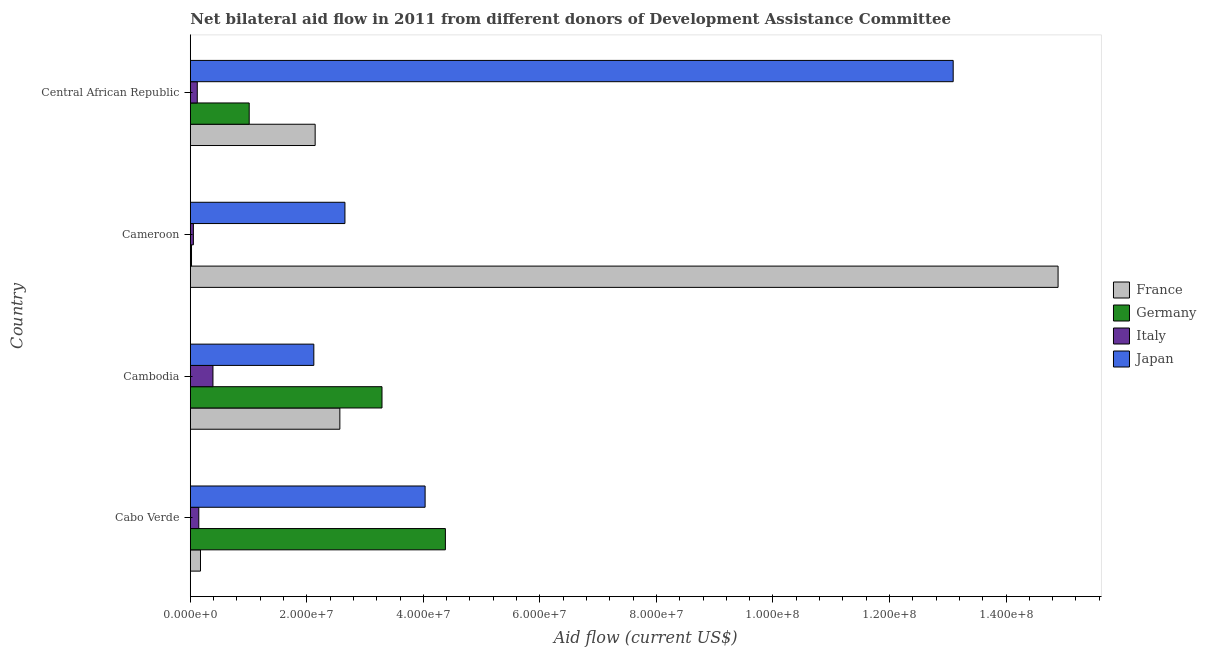How many different coloured bars are there?
Provide a short and direct response. 4. How many groups of bars are there?
Offer a terse response. 4. Are the number of bars per tick equal to the number of legend labels?
Your answer should be very brief. Yes. How many bars are there on the 1st tick from the top?
Your answer should be compact. 4. What is the label of the 1st group of bars from the top?
Ensure brevity in your answer.  Central African Republic. In how many cases, is the number of bars for a given country not equal to the number of legend labels?
Give a very brief answer. 0. What is the amount of aid given by france in Cabo Verde?
Give a very brief answer. 1.75e+06. Across all countries, what is the maximum amount of aid given by japan?
Offer a very short reply. 1.31e+08. Across all countries, what is the minimum amount of aid given by germany?
Offer a very short reply. 2.10e+05. In which country was the amount of aid given by france maximum?
Provide a short and direct response. Cameroon. In which country was the amount of aid given by germany minimum?
Make the answer very short. Cameroon. What is the total amount of aid given by japan in the graph?
Provide a succinct answer. 2.19e+08. What is the difference between the amount of aid given by france in Cabo Verde and that in Cambodia?
Give a very brief answer. -2.39e+07. What is the difference between the amount of aid given by italy in Cambodia and the amount of aid given by germany in Cabo Verde?
Offer a very short reply. -3.99e+07. What is the average amount of aid given by germany per country?
Your response must be concise. 2.18e+07. What is the difference between the amount of aid given by france and amount of aid given by italy in Cameroon?
Ensure brevity in your answer.  1.48e+08. What is the ratio of the amount of aid given by germany in Cabo Verde to that in Cameroon?
Your answer should be compact. 208.48. Is the difference between the amount of aid given by italy in Cameroon and Central African Republic greater than the difference between the amount of aid given by france in Cameroon and Central African Republic?
Keep it short and to the point. No. What is the difference between the highest and the second highest amount of aid given by italy?
Your answer should be very brief. 2.43e+06. What is the difference between the highest and the lowest amount of aid given by germany?
Give a very brief answer. 4.36e+07. In how many countries, is the amount of aid given by france greater than the average amount of aid given by france taken over all countries?
Offer a terse response. 1. Is the sum of the amount of aid given by japan in Cambodia and Cameroon greater than the maximum amount of aid given by italy across all countries?
Provide a succinct answer. Yes. Is it the case that in every country, the sum of the amount of aid given by japan and amount of aid given by france is greater than the sum of amount of aid given by germany and amount of aid given by italy?
Your answer should be very brief. No. What does the 3rd bar from the top in Cameroon represents?
Give a very brief answer. Germany. What does the 3rd bar from the bottom in Cabo Verde represents?
Make the answer very short. Italy. How many bars are there?
Give a very brief answer. 16. Are all the bars in the graph horizontal?
Offer a terse response. Yes. What is the difference between two consecutive major ticks on the X-axis?
Your response must be concise. 2.00e+07. Where does the legend appear in the graph?
Provide a succinct answer. Center right. How many legend labels are there?
Give a very brief answer. 4. What is the title of the graph?
Keep it short and to the point. Net bilateral aid flow in 2011 from different donors of Development Assistance Committee. What is the label or title of the X-axis?
Give a very brief answer. Aid flow (current US$). What is the Aid flow (current US$) in France in Cabo Verde?
Make the answer very short. 1.75e+06. What is the Aid flow (current US$) in Germany in Cabo Verde?
Your response must be concise. 4.38e+07. What is the Aid flow (current US$) of Italy in Cabo Verde?
Your answer should be compact. 1.46e+06. What is the Aid flow (current US$) in Japan in Cabo Verde?
Keep it short and to the point. 4.03e+07. What is the Aid flow (current US$) in France in Cambodia?
Ensure brevity in your answer.  2.57e+07. What is the Aid flow (current US$) of Germany in Cambodia?
Offer a terse response. 3.29e+07. What is the Aid flow (current US$) in Italy in Cambodia?
Your answer should be compact. 3.89e+06. What is the Aid flow (current US$) in Japan in Cambodia?
Offer a terse response. 2.12e+07. What is the Aid flow (current US$) in France in Cameroon?
Make the answer very short. 1.49e+08. What is the Aid flow (current US$) in Italy in Cameroon?
Offer a very short reply. 5.30e+05. What is the Aid flow (current US$) of Japan in Cameroon?
Offer a very short reply. 2.65e+07. What is the Aid flow (current US$) of France in Central African Republic?
Your answer should be compact. 2.14e+07. What is the Aid flow (current US$) of Germany in Central African Republic?
Make the answer very short. 1.01e+07. What is the Aid flow (current US$) of Italy in Central African Republic?
Provide a succinct answer. 1.20e+06. What is the Aid flow (current US$) of Japan in Central African Republic?
Offer a terse response. 1.31e+08. Across all countries, what is the maximum Aid flow (current US$) in France?
Your response must be concise. 1.49e+08. Across all countries, what is the maximum Aid flow (current US$) of Germany?
Give a very brief answer. 4.38e+07. Across all countries, what is the maximum Aid flow (current US$) in Italy?
Provide a succinct answer. 3.89e+06. Across all countries, what is the maximum Aid flow (current US$) in Japan?
Ensure brevity in your answer.  1.31e+08. Across all countries, what is the minimum Aid flow (current US$) of France?
Offer a terse response. 1.75e+06. Across all countries, what is the minimum Aid flow (current US$) in Germany?
Make the answer very short. 2.10e+05. Across all countries, what is the minimum Aid flow (current US$) of Italy?
Ensure brevity in your answer.  5.30e+05. Across all countries, what is the minimum Aid flow (current US$) of Japan?
Your answer should be compact. 2.12e+07. What is the total Aid flow (current US$) in France in the graph?
Your answer should be very brief. 1.98e+08. What is the total Aid flow (current US$) of Germany in the graph?
Your answer should be compact. 8.70e+07. What is the total Aid flow (current US$) of Italy in the graph?
Offer a very short reply. 7.08e+06. What is the total Aid flow (current US$) in Japan in the graph?
Offer a very short reply. 2.19e+08. What is the difference between the Aid flow (current US$) in France in Cabo Verde and that in Cambodia?
Offer a very short reply. -2.39e+07. What is the difference between the Aid flow (current US$) of Germany in Cabo Verde and that in Cambodia?
Provide a short and direct response. 1.09e+07. What is the difference between the Aid flow (current US$) of Italy in Cabo Verde and that in Cambodia?
Give a very brief answer. -2.43e+06. What is the difference between the Aid flow (current US$) in Japan in Cabo Verde and that in Cambodia?
Provide a succinct answer. 1.91e+07. What is the difference between the Aid flow (current US$) of France in Cabo Verde and that in Cameroon?
Your response must be concise. -1.47e+08. What is the difference between the Aid flow (current US$) in Germany in Cabo Verde and that in Cameroon?
Provide a succinct answer. 4.36e+07. What is the difference between the Aid flow (current US$) in Italy in Cabo Verde and that in Cameroon?
Your answer should be very brief. 9.30e+05. What is the difference between the Aid flow (current US$) of Japan in Cabo Verde and that in Cameroon?
Keep it short and to the point. 1.38e+07. What is the difference between the Aid flow (current US$) of France in Cabo Verde and that in Central African Republic?
Offer a very short reply. -1.97e+07. What is the difference between the Aid flow (current US$) of Germany in Cabo Verde and that in Central African Republic?
Your answer should be compact. 3.37e+07. What is the difference between the Aid flow (current US$) in Italy in Cabo Verde and that in Central African Republic?
Provide a short and direct response. 2.60e+05. What is the difference between the Aid flow (current US$) of Japan in Cabo Verde and that in Central African Republic?
Make the answer very short. -9.06e+07. What is the difference between the Aid flow (current US$) in France in Cambodia and that in Cameroon?
Give a very brief answer. -1.23e+08. What is the difference between the Aid flow (current US$) of Germany in Cambodia and that in Cameroon?
Your answer should be very brief. 3.27e+07. What is the difference between the Aid flow (current US$) in Italy in Cambodia and that in Cameroon?
Your response must be concise. 3.36e+06. What is the difference between the Aid flow (current US$) in Japan in Cambodia and that in Cameroon?
Your answer should be compact. -5.34e+06. What is the difference between the Aid flow (current US$) of France in Cambodia and that in Central African Republic?
Make the answer very short. 4.24e+06. What is the difference between the Aid flow (current US$) of Germany in Cambodia and that in Central African Republic?
Provide a short and direct response. 2.28e+07. What is the difference between the Aid flow (current US$) in Italy in Cambodia and that in Central African Republic?
Your response must be concise. 2.69e+06. What is the difference between the Aid flow (current US$) in Japan in Cambodia and that in Central African Republic?
Provide a short and direct response. -1.10e+08. What is the difference between the Aid flow (current US$) in France in Cameroon and that in Central African Republic?
Offer a terse response. 1.28e+08. What is the difference between the Aid flow (current US$) in Germany in Cameroon and that in Central African Republic?
Your answer should be compact. -9.90e+06. What is the difference between the Aid flow (current US$) of Italy in Cameroon and that in Central African Republic?
Provide a succinct answer. -6.70e+05. What is the difference between the Aid flow (current US$) in Japan in Cameroon and that in Central African Republic?
Ensure brevity in your answer.  -1.04e+08. What is the difference between the Aid flow (current US$) in France in Cabo Verde and the Aid flow (current US$) in Germany in Cambodia?
Your response must be concise. -3.12e+07. What is the difference between the Aid flow (current US$) of France in Cabo Verde and the Aid flow (current US$) of Italy in Cambodia?
Keep it short and to the point. -2.14e+06. What is the difference between the Aid flow (current US$) of France in Cabo Verde and the Aid flow (current US$) of Japan in Cambodia?
Your answer should be compact. -1.94e+07. What is the difference between the Aid flow (current US$) of Germany in Cabo Verde and the Aid flow (current US$) of Italy in Cambodia?
Your response must be concise. 3.99e+07. What is the difference between the Aid flow (current US$) of Germany in Cabo Verde and the Aid flow (current US$) of Japan in Cambodia?
Ensure brevity in your answer.  2.26e+07. What is the difference between the Aid flow (current US$) in Italy in Cabo Verde and the Aid flow (current US$) in Japan in Cambodia?
Make the answer very short. -1.97e+07. What is the difference between the Aid flow (current US$) in France in Cabo Verde and the Aid flow (current US$) in Germany in Cameroon?
Your response must be concise. 1.54e+06. What is the difference between the Aid flow (current US$) in France in Cabo Verde and the Aid flow (current US$) in Italy in Cameroon?
Offer a terse response. 1.22e+06. What is the difference between the Aid flow (current US$) in France in Cabo Verde and the Aid flow (current US$) in Japan in Cameroon?
Give a very brief answer. -2.48e+07. What is the difference between the Aid flow (current US$) of Germany in Cabo Verde and the Aid flow (current US$) of Italy in Cameroon?
Offer a very short reply. 4.32e+07. What is the difference between the Aid flow (current US$) in Germany in Cabo Verde and the Aid flow (current US$) in Japan in Cameroon?
Offer a very short reply. 1.72e+07. What is the difference between the Aid flow (current US$) of Italy in Cabo Verde and the Aid flow (current US$) of Japan in Cameroon?
Provide a short and direct response. -2.51e+07. What is the difference between the Aid flow (current US$) of France in Cabo Verde and the Aid flow (current US$) of Germany in Central African Republic?
Provide a short and direct response. -8.36e+06. What is the difference between the Aid flow (current US$) of France in Cabo Verde and the Aid flow (current US$) of Japan in Central African Republic?
Provide a succinct answer. -1.29e+08. What is the difference between the Aid flow (current US$) of Germany in Cabo Verde and the Aid flow (current US$) of Italy in Central African Republic?
Your response must be concise. 4.26e+07. What is the difference between the Aid flow (current US$) in Germany in Cabo Verde and the Aid flow (current US$) in Japan in Central African Republic?
Your answer should be compact. -8.72e+07. What is the difference between the Aid flow (current US$) in Italy in Cabo Verde and the Aid flow (current US$) in Japan in Central African Republic?
Your response must be concise. -1.29e+08. What is the difference between the Aid flow (current US$) in France in Cambodia and the Aid flow (current US$) in Germany in Cameroon?
Your response must be concise. 2.55e+07. What is the difference between the Aid flow (current US$) of France in Cambodia and the Aid flow (current US$) of Italy in Cameroon?
Provide a short and direct response. 2.51e+07. What is the difference between the Aid flow (current US$) of France in Cambodia and the Aid flow (current US$) of Japan in Cameroon?
Provide a short and direct response. -8.70e+05. What is the difference between the Aid flow (current US$) of Germany in Cambodia and the Aid flow (current US$) of Italy in Cameroon?
Ensure brevity in your answer.  3.24e+07. What is the difference between the Aid flow (current US$) of Germany in Cambodia and the Aid flow (current US$) of Japan in Cameroon?
Offer a terse response. 6.36e+06. What is the difference between the Aid flow (current US$) of Italy in Cambodia and the Aid flow (current US$) of Japan in Cameroon?
Your response must be concise. -2.26e+07. What is the difference between the Aid flow (current US$) of France in Cambodia and the Aid flow (current US$) of Germany in Central African Republic?
Provide a succinct answer. 1.56e+07. What is the difference between the Aid flow (current US$) of France in Cambodia and the Aid flow (current US$) of Italy in Central African Republic?
Your answer should be very brief. 2.45e+07. What is the difference between the Aid flow (current US$) in France in Cambodia and the Aid flow (current US$) in Japan in Central African Republic?
Keep it short and to the point. -1.05e+08. What is the difference between the Aid flow (current US$) of Germany in Cambodia and the Aid flow (current US$) of Italy in Central African Republic?
Ensure brevity in your answer.  3.17e+07. What is the difference between the Aid flow (current US$) in Germany in Cambodia and the Aid flow (current US$) in Japan in Central African Republic?
Your answer should be compact. -9.80e+07. What is the difference between the Aid flow (current US$) in Italy in Cambodia and the Aid flow (current US$) in Japan in Central African Republic?
Provide a short and direct response. -1.27e+08. What is the difference between the Aid flow (current US$) of France in Cameroon and the Aid flow (current US$) of Germany in Central African Republic?
Ensure brevity in your answer.  1.39e+08. What is the difference between the Aid flow (current US$) in France in Cameroon and the Aid flow (current US$) in Italy in Central African Republic?
Give a very brief answer. 1.48e+08. What is the difference between the Aid flow (current US$) of France in Cameroon and the Aid flow (current US$) of Japan in Central African Republic?
Give a very brief answer. 1.80e+07. What is the difference between the Aid flow (current US$) in Germany in Cameroon and the Aid flow (current US$) in Italy in Central African Republic?
Give a very brief answer. -9.90e+05. What is the difference between the Aid flow (current US$) of Germany in Cameroon and the Aid flow (current US$) of Japan in Central African Republic?
Your response must be concise. -1.31e+08. What is the difference between the Aid flow (current US$) in Italy in Cameroon and the Aid flow (current US$) in Japan in Central African Republic?
Keep it short and to the point. -1.30e+08. What is the average Aid flow (current US$) in France per country?
Provide a succinct answer. 4.94e+07. What is the average Aid flow (current US$) of Germany per country?
Keep it short and to the point. 2.18e+07. What is the average Aid flow (current US$) of Italy per country?
Keep it short and to the point. 1.77e+06. What is the average Aid flow (current US$) of Japan per country?
Provide a succinct answer. 5.47e+07. What is the difference between the Aid flow (current US$) of France and Aid flow (current US$) of Germany in Cabo Verde?
Offer a very short reply. -4.20e+07. What is the difference between the Aid flow (current US$) of France and Aid flow (current US$) of Japan in Cabo Verde?
Your answer should be very brief. -3.86e+07. What is the difference between the Aid flow (current US$) of Germany and Aid flow (current US$) of Italy in Cabo Verde?
Keep it short and to the point. 4.23e+07. What is the difference between the Aid flow (current US$) of Germany and Aid flow (current US$) of Japan in Cabo Verde?
Keep it short and to the point. 3.48e+06. What is the difference between the Aid flow (current US$) of Italy and Aid flow (current US$) of Japan in Cabo Verde?
Your answer should be compact. -3.88e+07. What is the difference between the Aid flow (current US$) in France and Aid flow (current US$) in Germany in Cambodia?
Make the answer very short. -7.23e+06. What is the difference between the Aid flow (current US$) in France and Aid flow (current US$) in Italy in Cambodia?
Give a very brief answer. 2.18e+07. What is the difference between the Aid flow (current US$) in France and Aid flow (current US$) in Japan in Cambodia?
Ensure brevity in your answer.  4.47e+06. What is the difference between the Aid flow (current US$) in Germany and Aid flow (current US$) in Italy in Cambodia?
Provide a succinct answer. 2.90e+07. What is the difference between the Aid flow (current US$) in Germany and Aid flow (current US$) in Japan in Cambodia?
Your response must be concise. 1.17e+07. What is the difference between the Aid flow (current US$) of Italy and Aid flow (current US$) of Japan in Cambodia?
Provide a succinct answer. -1.73e+07. What is the difference between the Aid flow (current US$) in France and Aid flow (current US$) in Germany in Cameroon?
Keep it short and to the point. 1.49e+08. What is the difference between the Aid flow (current US$) of France and Aid flow (current US$) of Italy in Cameroon?
Provide a short and direct response. 1.48e+08. What is the difference between the Aid flow (current US$) in France and Aid flow (current US$) in Japan in Cameroon?
Give a very brief answer. 1.22e+08. What is the difference between the Aid flow (current US$) in Germany and Aid flow (current US$) in Italy in Cameroon?
Offer a terse response. -3.20e+05. What is the difference between the Aid flow (current US$) in Germany and Aid flow (current US$) in Japan in Cameroon?
Make the answer very short. -2.63e+07. What is the difference between the Aid flow (current US$) in Italy and Aid flow (current US$) in Japan in Cameroon?
Give a very brief answer. -2.60e+07. What is the difference between the Aid flow (current US$) of France and Aid flow (current US$) of Germany in Central African Republic?
Provide a succinct answer. 1.13e+07. What is the difference between the Aid flow (current US$) in France and Aid flow (current US$) in Italy in Central African Republic?
Your answer should be compact. 2.02e+07. What is the difference between the Aid flow (current US$) in France and Aid flow (current US$) in Japan in Central African Republic?
Your answer should be compact. -1.10e+08. What is the difference between the Aid flow (current US$) of Germany and Aid flow (current US$) of Italy in Central African Republic?
Offer a very short reply. 8.91e+06. What is the difference between the Aid flow (current US$) of Germany and Aid flow (current US$) of Japan in Central African Republic?
Provide a succinct answer. -1.21e+08. What is the difference between the Aid flow (current US$) of Italy and Aid flow (current US$) of Japan in Central African Republic?
Your answer should be compact. -1.30e+08. What is the ratio of the Aid flow (current US$) in France in Cabo Verde to that in Cambodia?
Your answer should be very brief. 0.07. What is the ratio of the Aid flow (current US$) of Germany in Cabo Verde to that in Cambodia?
Your response must be concise. 1.33. What is the ratio of the Aid flow (current US$) in Italy in Cabo Verde to that in Cambodia?
Provide a short and direct response. 0.38. What is the ratio of the Aid flow (current US$) in Japan in Cabo Verde to that in Cambodia?
Offer a terse response. 1.9. What is the ratio of the Aid flow (current US$) in France in Cabo Verde to that in Cameroon?
Provide a succinct answer. 0.01. What is the ratio of the Aid flow (current US$) of Germany in Cabo Verde to that in Cameroon?
Make the answer very short. 208.48. What is the ratio of the Aid flow (current US$) of Italy in Cabo Verde to that in Cameroon?
Ensure brevity in your answer.  2.75. What is the ratio of the Aid flow (current US$) of Japan in Cabo Verde to that in Cameroon?
Make the answer very short. 1.52. What is the ratio of the Aid flow (current US$) of France in Cabo Verde to that in Central African Republic?
Your answer should be compact. 0.08. What is the ratio of the Aid flow (current US$) of Germany in Cabo Verde to that in Central African Republic?
Provide a short and direct response. 4.33. What is the ratio of the Aid flow (current US$) of Italy in Cabo Verde to that in Central African Republic?
Offer a terse response. 1.22. What is the ratio of the Aid flow (current US$) of Japan in Cabo Verde to that in Central African Republic?
Keep it short and to the point. 0.31. What is the ratio of the Aid flow (current US$) in France in Cambodia to that in Cameroon?
Your answer should be very brief. 0.17. What is the ratio of the Aid flow (current US$) of Germany in Cambodia to that in Cameroon?
Offer a very short reply. 156.67. What is the ratio of the Aid flow (current US$) of Italy in Cambodia to that in Cameroon?
Your response must be concise. 7.34. What is the ratio of the Aid flow (current US$) of Japan in Cambodia to that in Cameroon?
Provide a succinct answer. 0.8. What is the ratio of the Aid flow (current US$) in France in Cambodia to that in Central African Republic?
Give a very brief answer. 1.2. What is the ratio of the Aid flow (current US$) of Germany in Cambodia to that in Central African Republic?
Give a very brief answer. 3.25. What is the ratio of the Aid flow (current US$) in Italy in Cambodia to that in Central African Republic?
Your response must be concise. 3.24. What is the ratio of the Aid flow (current US$) of Japan in Cambodia to that in Central African Republic?
Provide a short and direct response. 0.16. What is the ratio of the Aid flow (current US$) in France in Cameroon to that in Central African Republic?
Offer a terse response. 6.95. What is the ratio of the Aid flow (current US$) of Germany in Cameroon to that in Central African Republic?
Offer a terse response. 0.02. What is the ratio of the Aid flow (current US$) of Italy in Cameroon to that in Central African Republic?
Your response must be concise. 0.44. What is the ratio of the Aid flow (current US$) of Japan in Cameroon to that in Central African Republic?
Provide a succinct answer. 0.2. What is the difference between the highest and the second highest Aid flow (current US$) of France?
Keep it short and to the point. 1.23e+08. What is the difference between the highest and the second highest Aid flow (current US$) in Germany?
Offer a very short reply. 1.09e+07. What is the difference between the highest and the second highest Aid flow (current US$) of Italy?
Offer a terse response. 2.43e+06. What is the difference between the highest and the second highest Aid flow (current US$) of Japan?
Your answer should be compact. 9.06e+07. What is the difference between the highest and the lowest Aid flow (current US$) in France?
Provide a succinct answer. 1.47e+08. What is the difference between the highest and the lowest Aid flow (current US$) in Germany?
Your response must be concise. 4.36e+07. What is the difference between the highest and the lowest Aid flow (current US$) of Italy?
Keep it short and to the point. 3.36e+06. What is the difference between the highest and the lowest Aid flow (current US$) of Japan?
Ensure brevity in your answer.  1.10e+08. 